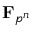<formula> <loc_0><loc_0><loc_500><loc_500>F _ { p ^ { n } }</formula> 